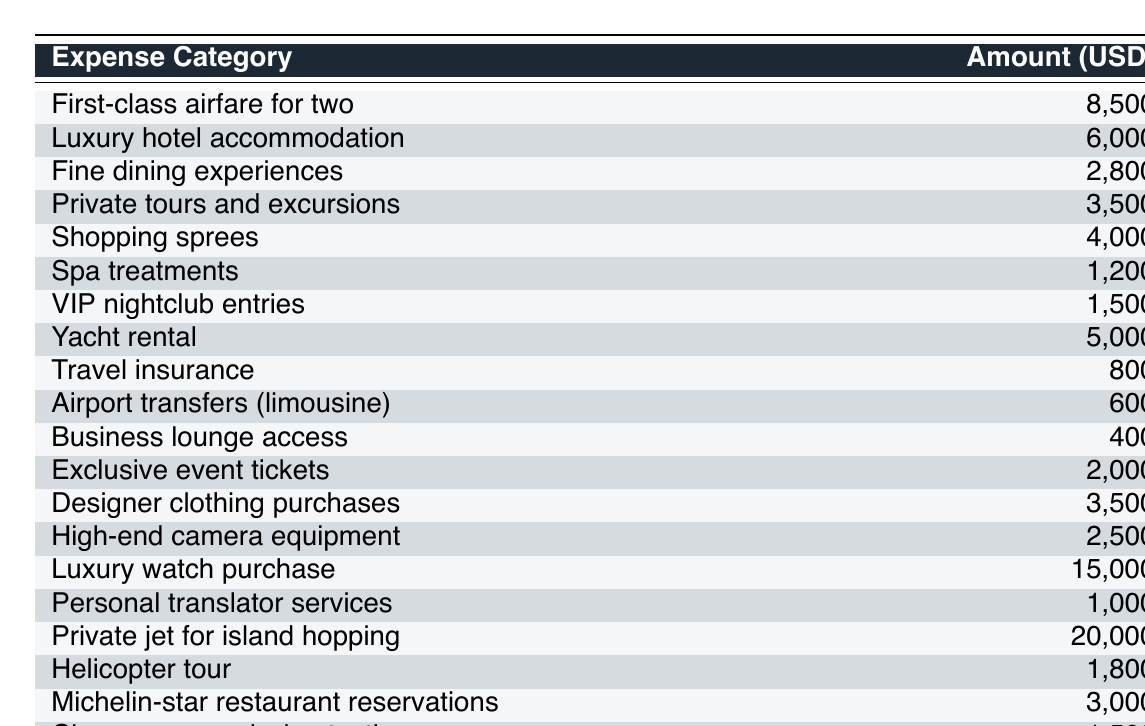What is the total amount spent on luxury accommodation and first-class airfare? To find the total, we add the costs of luxury hotel accommodation and first-class airfare for two. From the table, the luxury hotel accommodation is 6,000 USD and airfare is 8,500 USD. So, 6,000 + 8,500 = 14,500 USD.
Answer: 14,500 USD What is the most expensive single expense in the table? The most expensive single expense is the private jet for island hopping, which costs 20,000 USD. This can be seen directly in the table under the "Amount (USD)" column.
Answer: 20,000 USD How much did I spend on fine dining experiences and Michelin-star restaurant reservations combined? We add the expenses for fine dining experiences (2,800 USD) and Michelin-star restaurant reservations (3,000 USD). Therefore, 2,800 + 3,000 = 5,800 USD.
Answer: 5,800 USD Is the cost of luxury watch purchase greater than that of the private tours and excursions? The luxury watch purchase costs 15,000 USD, while private tours and excursions cost 3,500 USD. Since 15,000 is greater than 3,500, the statement is true.
Answer: Yes What is the total amount spent on spa treatments, champagne and wine tasting, and VIP nightclub entries? To calculate the total, we add the costs: spa treatments (1,200 USD), champagne and wine tasting (1,500 USD), and VIP nightclub entries (1,500 USD). So, 1,200 + 1,500 + 1,500 = 4,200 USD.
Answer: 4,200 USD What percentage of the total trip expenses does the yacht rental represent? First, we find the total expenses by summing all amounts in the table to get 82,900 USD. The yacht rental is 5,000 USD. Now we calculate the percentage: (5,000 / 82,900) * 100, which is approximately 6.03%.
Answer: 6.03% How much more is spent on designer clothing purchases compared to private tours and excursions? Designer clothing purchases cost 3,500 USD, and private tours and excursions cost 3,500 USD as well. The difference is 3,500 - 3,500 = 0 USD.
Answer: 0 USD What is the average cost of all listed expenses? There are 20 expense categories listed. To find the average, we add all expenses (total is 82,900 USD) and divide by the number of categories: 82,900 / 20 = 4,145 USD.
Answer: 4,145 USD Are airport transfers more expensive than travel insurance? The cost of airport transfers is 600 USD, and travel insurance costs 800 USD. Since 600 is less than 800, the statement is false.
Answer: No What is the combined amount spent on helicopter tours and private translator services? We add the helicopter tour cost (1,800 USD) and the personal translator services (1,000 USD): 1,800 + 1,000 = 2,800 USD.
Answer: 2,800 USD 